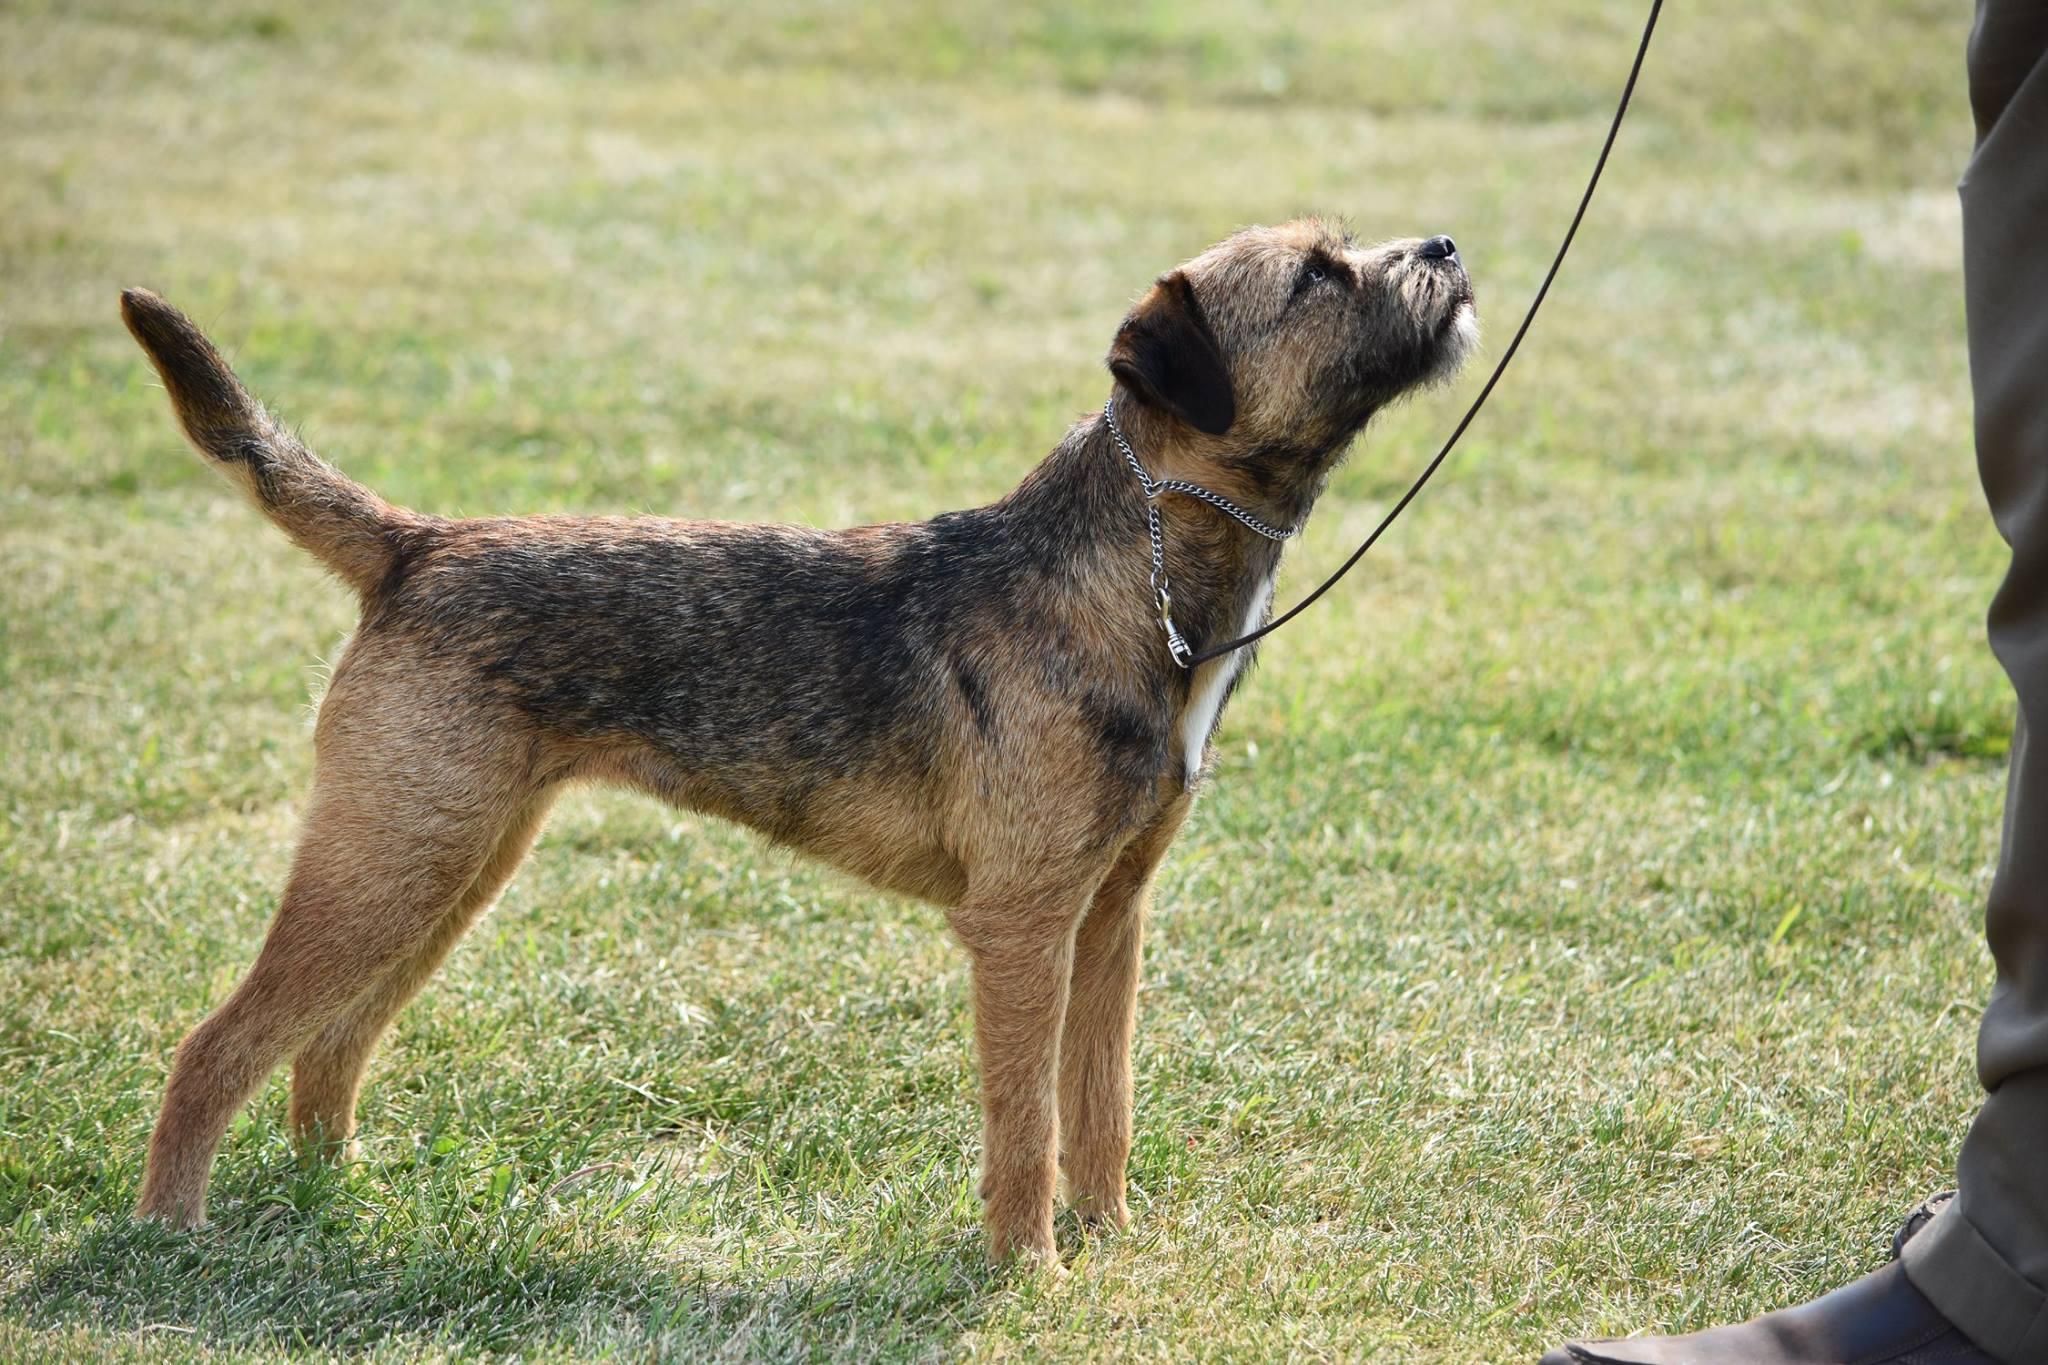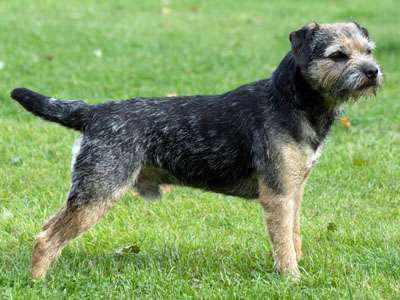The first image is the image on the left, the second image is the image on the right. Assess this claim about the two images: "A dog is standing on grass.". Correct or not? Answer yes or no. Yes. The first image is the image on the left, the second image is the image on the right. For the images shown, is this caption "The combined images include two dogs with bodies turned rightward in profile, and at least one dog with its head raised and gazing up to the right." true? Answer yes or no. Yes. 